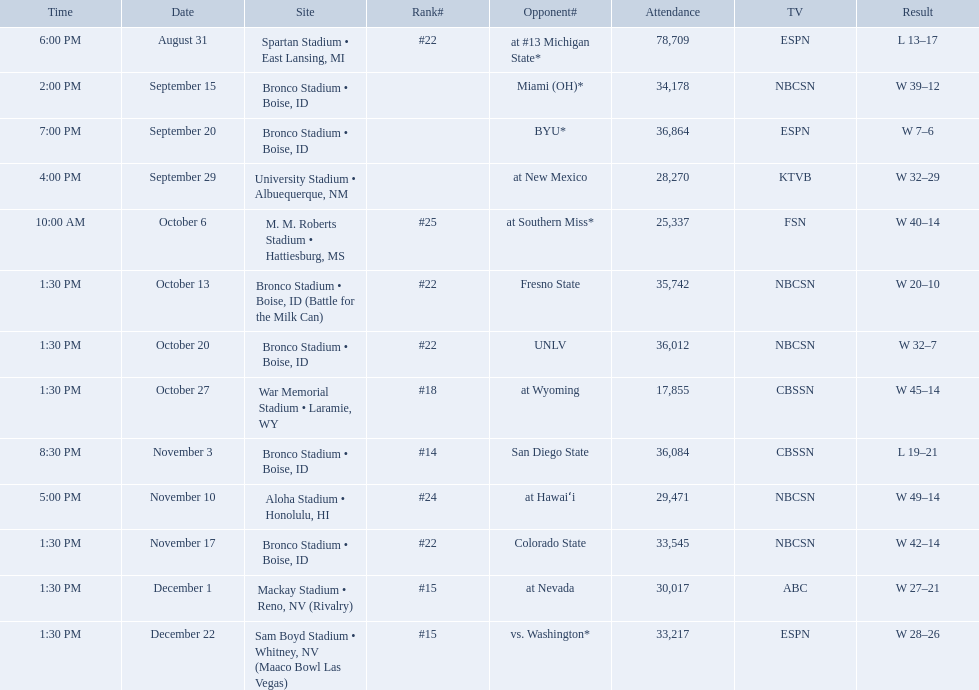What was the team's listed rankings for the season? #22, , , , #25, #22, #22, #18, #14, #24, #22, #15, #15. Which of these ranks is the best? #14. 